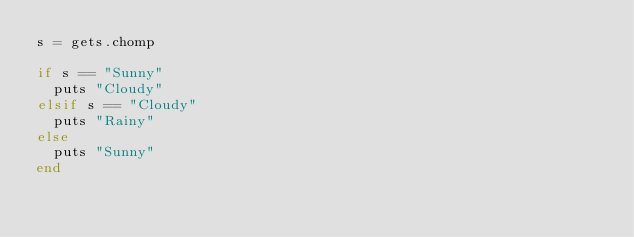<code> <loc_0><loc_0><loc_500><loc_500><_Ruby_>s = gets.chomp

if s == "Sunny"
  puts "Cloudy"
elsif s == "Cloudy"
  puts "Rainy"
else
  puts "Sunny"
end</code> 